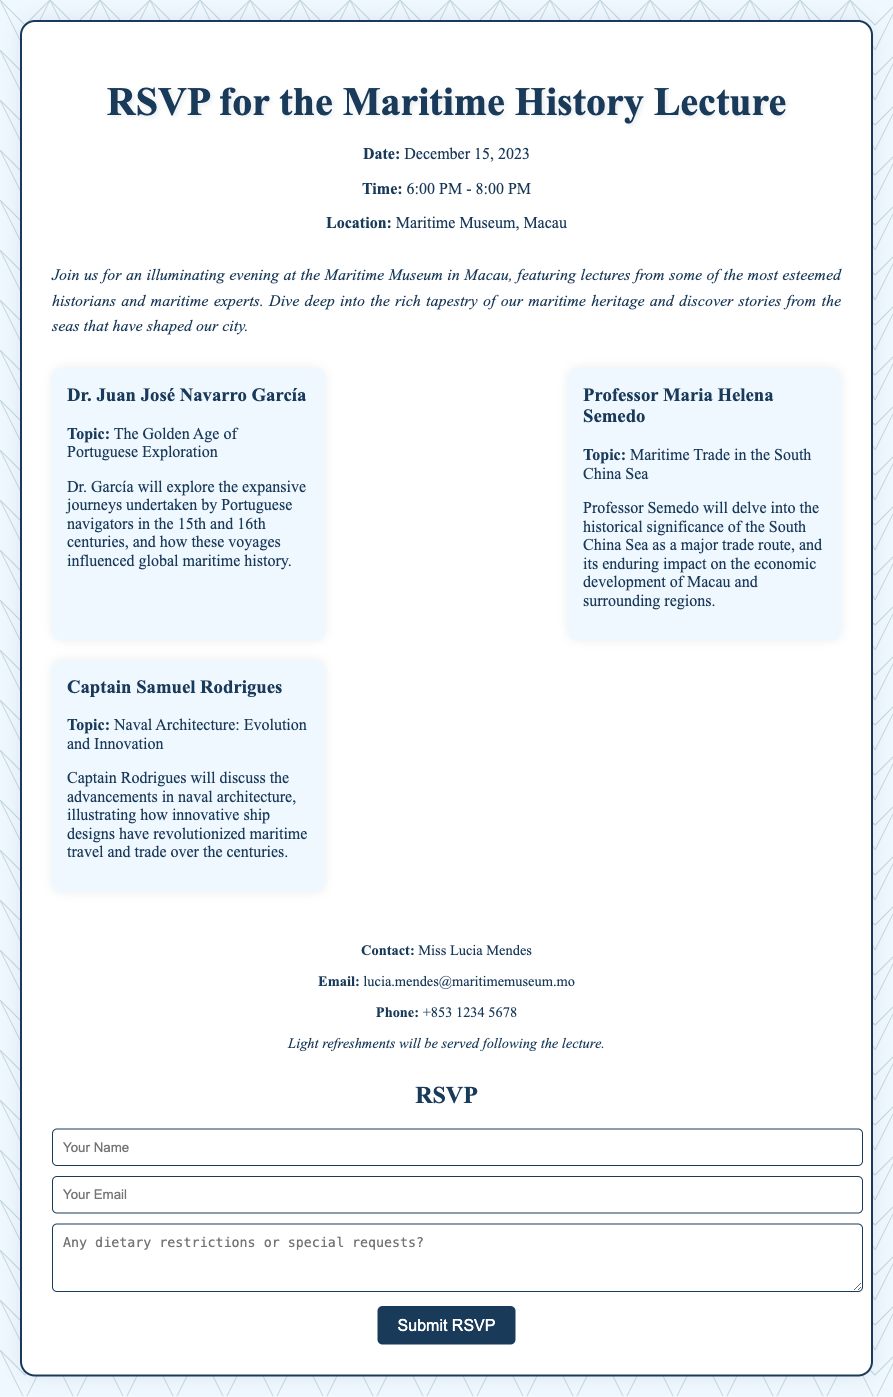What is the date of the event? The date of the event is specified in the document as December 15, 2023.
Answer: December 15, 2023 Who is the speaker on the topic of Naval Architecture? The document lists Captain Samuel Rodrigues as the speaker discussing the topic of Naval Architecture.
Answer: Captain Samuel Rodrigues What time does the lecture start? The starting time of the lecture is mentioned in the document as 6:00 PM.
Answer: 6:00 PM What is the location of the Maritime History Lecture? The document states that the lecture will take place at the Maritime Museum, Macau.
Answer: Maritime Museum, Macau Which topic will Dr. Juan José Navarro García discuss? The topic assigned to Dr. Juan José Navarro García is the Golden Age of Portuguese Exploration.
Answer: The Golden Age of Portuguese Exploration What kind of refreshments will be served after the lecture? The document mentions that light refreshments will be served following the lecture.
Answer: Light refreshments How can one contact Miss Lucia Mendes? The document provides contact details for Miss Lucia Mendes, including email and phone number.
Answer: lucia.mendes@maritimemuseum.mo What is required in the RSVP form? The RSVP form requests the participant's name, email, and any dietary restrictions or special requests.
Answer: Your Name, Your Email, dietary restrictions What is the purpose of the event? The document describes the purpose of the event as an illuminating evening featuring lectures on maritime history.
Answer: Maritime history lectures 